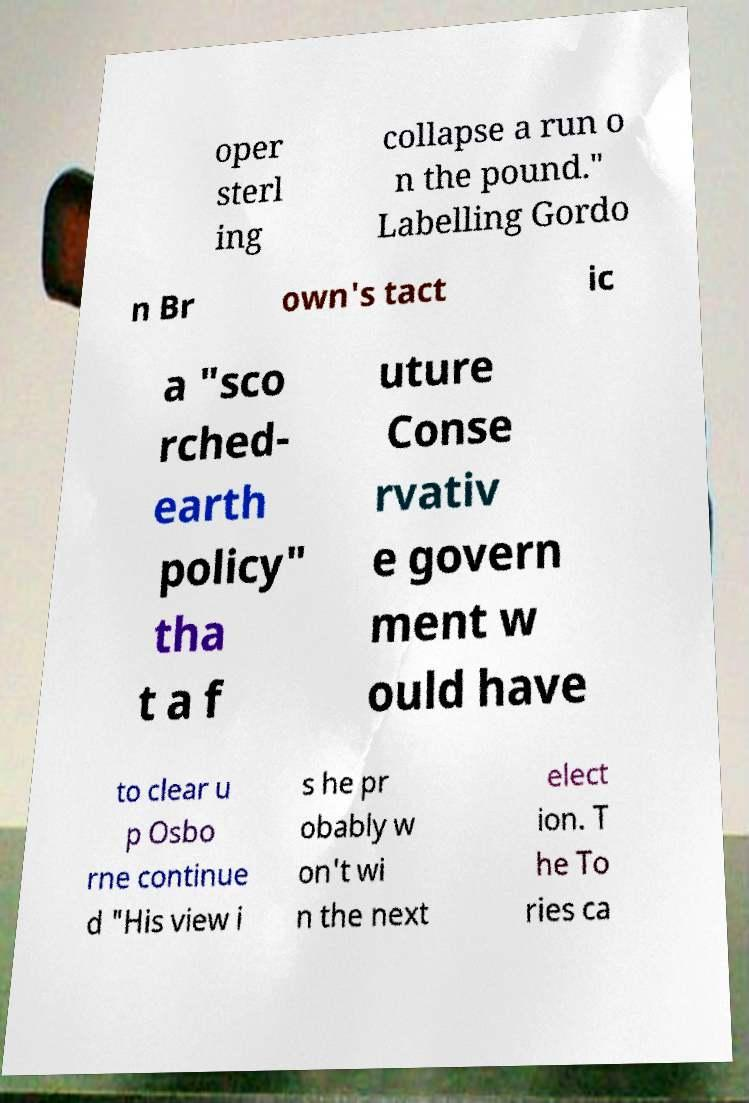Can you read and provide the text displayed in the image?This photo seems to have some interesting text. Can you extract and type it out for me? oper sterl ing collapse a run o n the pound." Labelling Gordo n Br own's tact ic a "sco rched- earth policy" tha t a f uture Conse rvativ e govern ment w ould have to clear u p Osbo rne continue d "His view i s he pr obably w on't wi n the next elect ion. T he To ries ca 